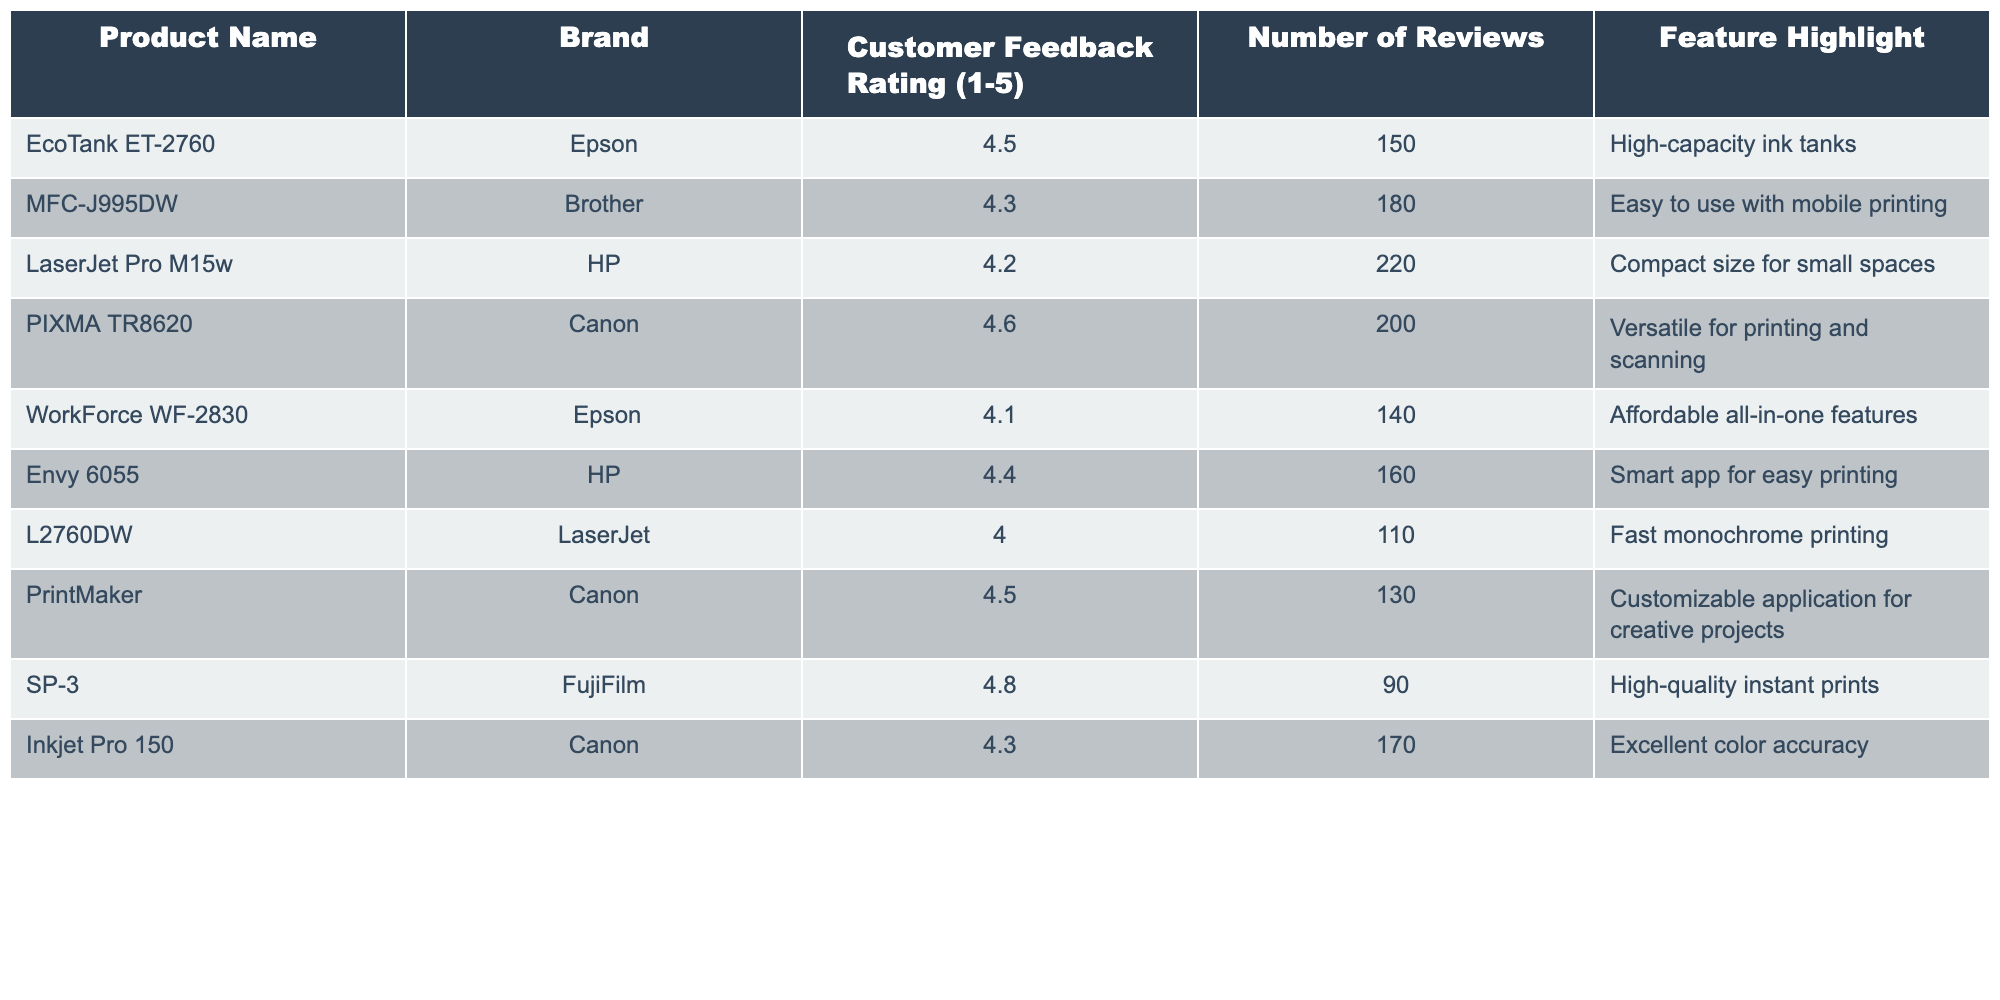What is the highest customer feedback rating? The highest rating in the table is found by comparing the "Customer Feedback Rating" column, which shows 4.8 for the SP-3 product.
Answer: 4.8 Which product has the most reviews? By examining the "Number of Reviews" column, the LaserJet Pro M15w has the highest number with 220 reviews.
Answer: LaserJet Pro M15w Are all products rated above 3.0? All ratings listed in the table are above 3.0, as the minimum rating is 4.0 for the L2760DW.
Answer: Yes What is the average customer feedback rating for Epson products? The ratings for Epson products are 4.5, 4.1, and the average is calculated as (4.5 + 4.1) / 2 = 4.3.
Answer: 4.3 Which brand has the highest-rated product and what is that rating? The FujiFilm SP-3 has the highest rating of 4.8, compared to all brands listed.
Answer: FujiFilm, 4.8 How many products have a feedback rating of 4.3 or higher? By counting the entries with ratings above 4.3 in the "Customer Feedback Rating" column: 5 products qualify (EcoTank ET-2760, PIXMA TR8620, Envy 6055, PrintMaker, and SP-3).
Answer: 5 Which product is noted for its "High-capacity ink tanks"? The EcoTank ET-2760 is highlighted for its "High-capacity ink tanks" feature.
Answer: EcoTank ET-2760 What is the total number of reviews for HP products? The reviews for HP products are 220 for LaserJet Pro M15w and 160 for Envy 6055. Summing these gives 220 + 160 = 380 reviews.
Answer: 380 Which product is best for users looking for customizable applications? The PrintMaker by Canon is the product recommended for users interested in customizable applications for creative projects.
Answer: PrintMaker How much higher is the rating for SP-3 than for WorkForce WF-2830? The rating for SP-3 is 4.8 and for WorkForce WF-2830 is 4.1. The difference is 4.8 - 4.1 = 0.7.
Answer: 0.7 